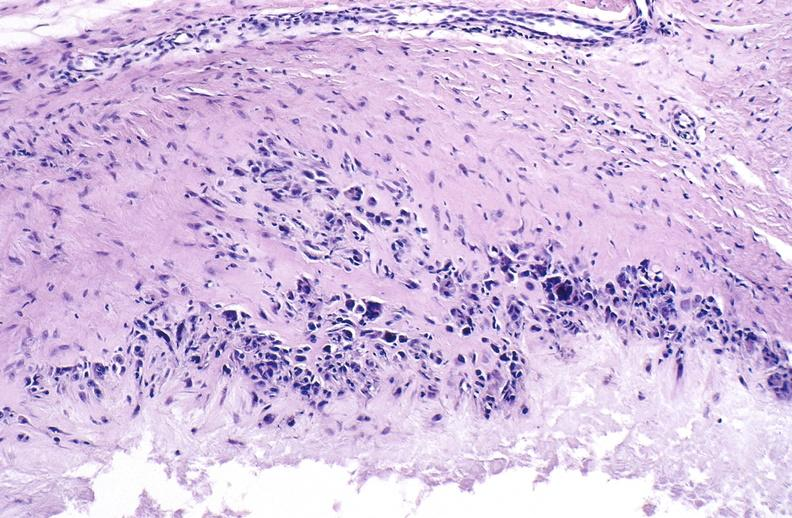s joints present?
Answer the question using a single word or phrase. Yes 